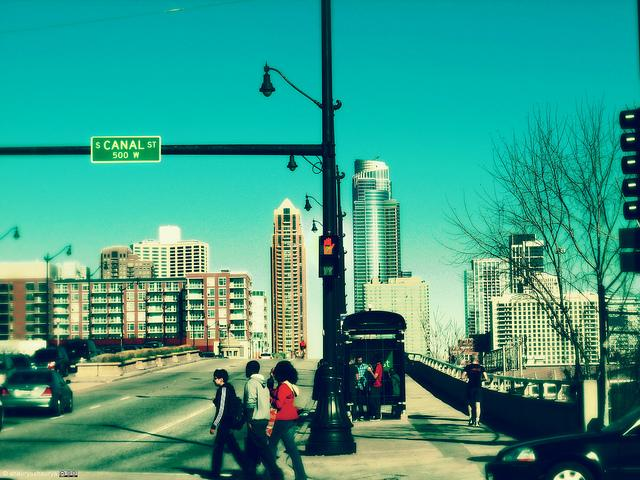What is the hand on the traffic light telling those facing it?

Choices:
A) go left
B) walk
C) go right
D) stop stop 